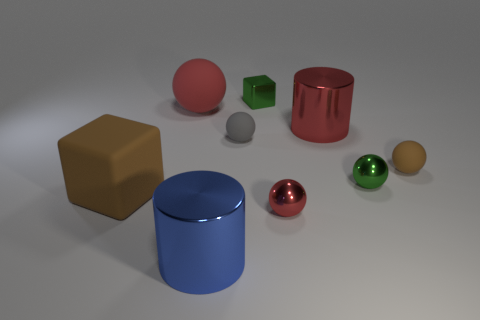Subtract all yellow cylinders. How many red balls are left? 2 Subtract all brown matte spheres. How many spheres are left? 4 Subtract all green balls. How many balls are left? 4 Subtract 3 balls. How many balls are left? 2 Subtract all yellow spheres. Subtract all green blocks. How many spheres are left? 5 Subtract all cubes. How many objects are left? 7 Subtract all yellow spheres. Subtract all large cylinders. How many objects are left? 7 Add 8 small green things. How many small green things are left? 10 Add 5 small green spheres. How many small green spheres exist? 6 Subtract 2 red balls. How many objects are left? 7 